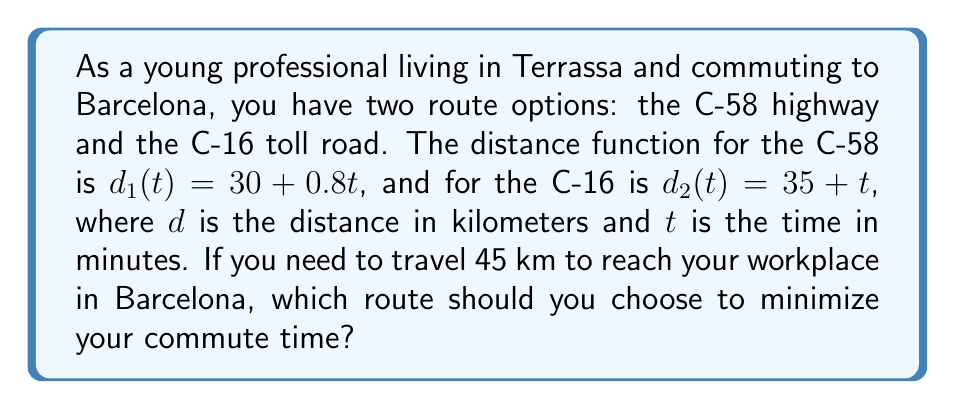Teach me how to tackle this problem. Let's solve this step-by-step:

1) We need to find the time $t$ for each route when the distance is 45 km.

2) For the C-58 (Route 1):
   $45 = 30 + 0.8t$
   $15 = 0.8t$
   $t_1 = 15 / 0.8 = 18.75$ minutes

3) For the C-16 (Route 2):
   $45 = 35 + t$
   $t_2 = 10$ minutes

4) Compare the times:
   C-58 (Route 1): 18.75 minutes
   C-16 (Route 2): 10 minutes

5) The C-16 (Route 2) is faster by 8.75 minutes.

Therefore, to minimize commute time, you should choose the C-16 toll road.
Answer: C-16 toll road 